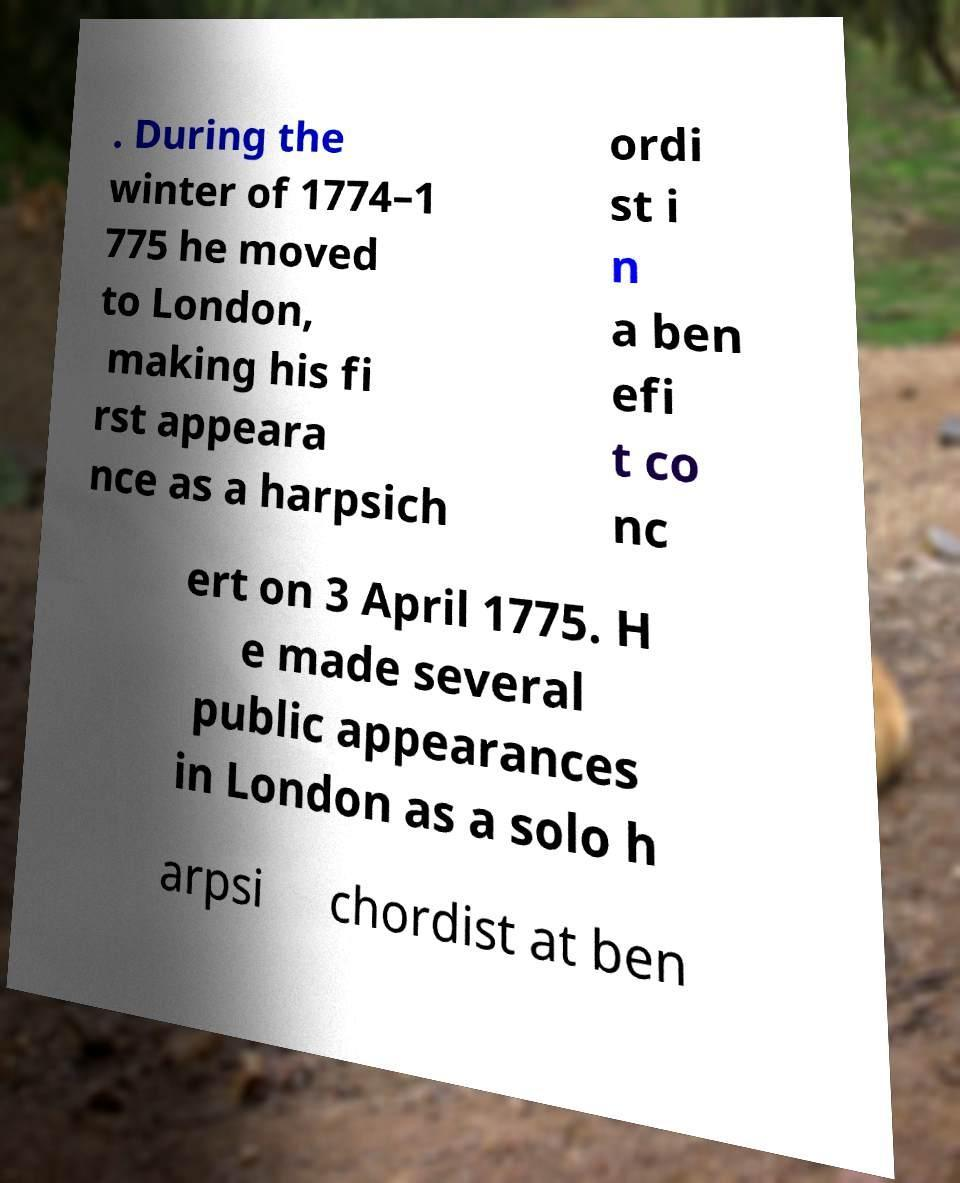Please read and relay the text visible in this image. What does it say? . During the winter of 1774–1 775 he moved to London, making his fi rst appeara nce as a harpsich ordi st i n a ben efi t co nc ert on 3 April 1775. H e made several public appearances in London as a solo h arpsi chordist at ben 